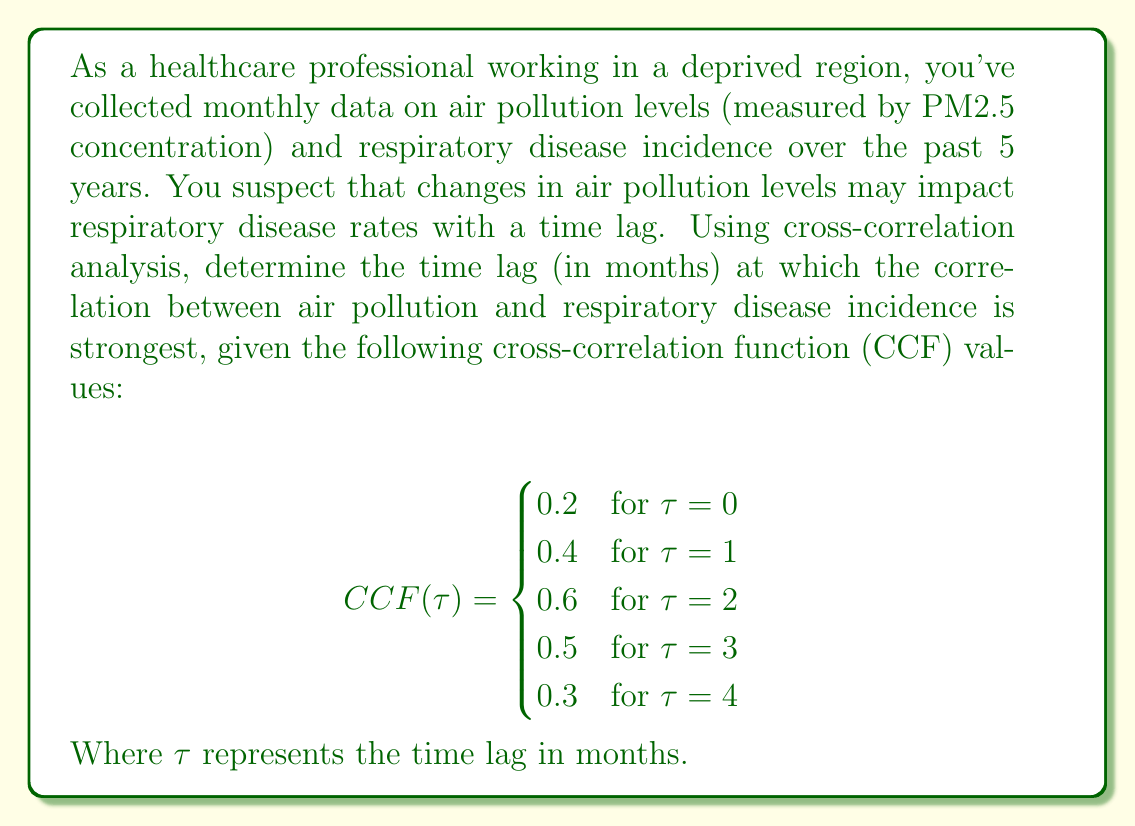Teach me how to tackle this problem. To determine the time lag at which the correlation between air pollution and respiratory disease incidence is strongest, we need to analyze the cross-correlation function (CCF) values provided.

The cross-correlation function measures the similarity between two time series as a function of the time lag between them. In this case, we're examining the relationship between air pollution levels and respiratory disease incidence.

Let's break down the given information:

1. $CCF(0) = 0.2$: Correlation with no time lag
2. $CCF(1) = 0.4$: Correlation with a 1-month lag
3. $CCF(2) = 0.6$: Correlation with a 2-month lag
4. $CCF(3) = 0.5$: Correlation with a 3-month lag
5. $CCF(4) = 0.3$: Correlation with a 4-month lag

To find the strongest correlation, we need to identify the maximum CCF value:

$$\max_{0 \leq \tau \leq 4} CCF(\tau) = 0.6$$

This maximum value occurs when $\tau = 2$.

Therefore, the strongest correlation between air pollution levels and respiratory disease incidence occurs with a 2-month time lag. This suggests that changes in air pollution levels are most strongly associated with changes in respiratory disease rates two months later.

This finding is crucial for healthcare professionals working in deprived regions, as it can help in predicting and preparing for potential increases in respiratory disease cases based on current air pollution levels.
Answer: The time lag at which the correlation between air pollution and respiratory disease incidence is strongest is 2 months. 